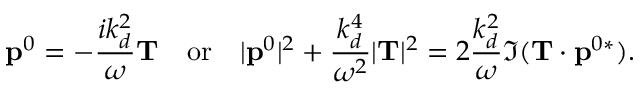<formula> <loc_0><loc_0><loc_500><loc_500>{ p } ^ { 0 } = - \frac { i k _ { d } ^ { 2 } } { \omega } { T } \quad o r \quad | { p } ^ { 0 } | ^ { 2 } + \frac { k _ { d } ^ { 4 } } { \omega ^ { 2 } } | { T } | ^ { 2 } = 2 \frac { k _ { d } ^ { 2 } } { \omega } \Im ( { T } \cdot { p } ^ { 0 * } ) .</formula> 